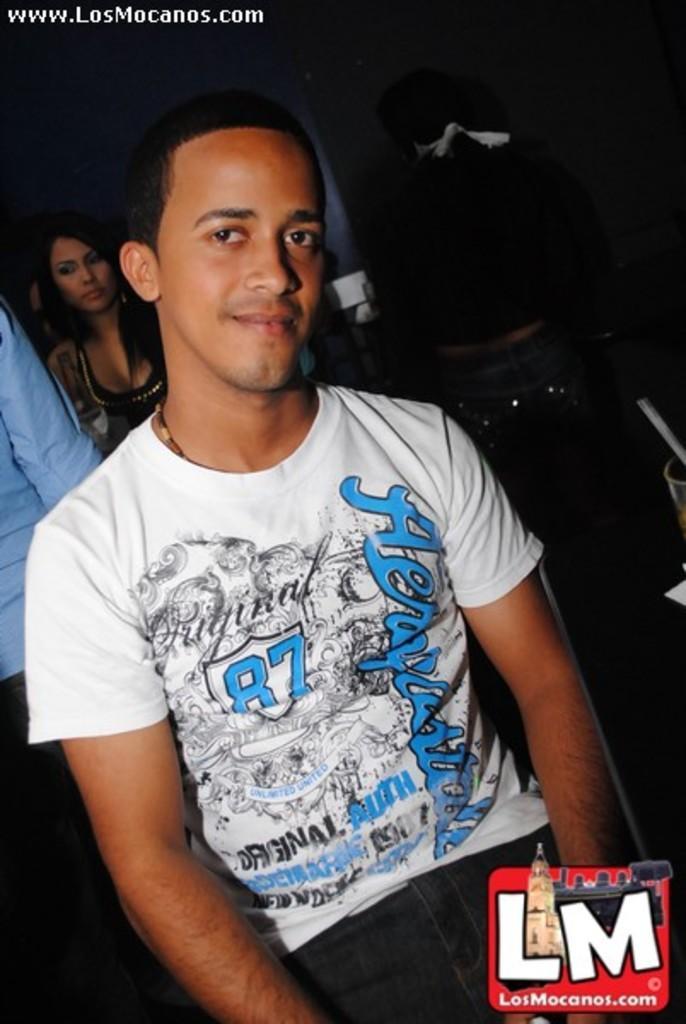Please provide a concise description of this image. In this image in the foreground there is one man, and in the background there are some people who are standing and there is a wall and some other objects. 